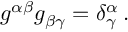<formula> <loc_0><loc_0><loc_500><loc_500>g ^ { \alpha \beta } g _ { \beta \gamma } = \delta _ { \gamma } ^ { \alpha } \, .</formula> 